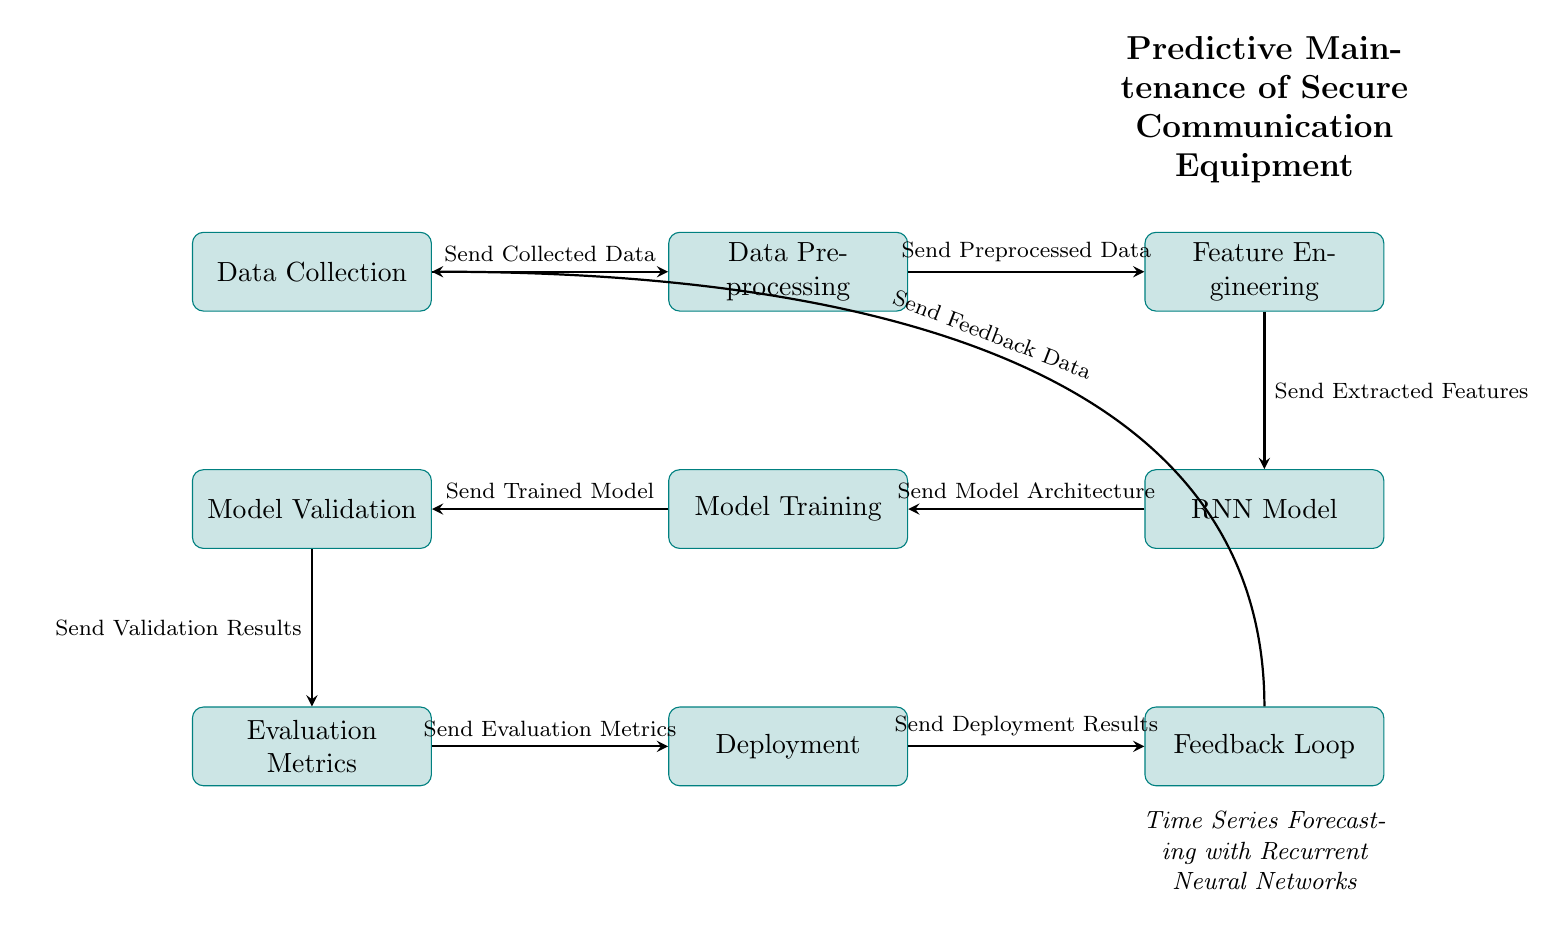What is the first step in the process? The first step in the process is represented by the node labeled "Data Collection," which is the starting point where relevant data is gathered before any further processing.
Answer: Data Collection How many main processes are there in the diagram? The diagram features eight main processes, which include Data Collection, Data Preprocessing, Feature Engineering, RNN Model, Model Training, Model Validation, Evaluation Metrics, Deployment, and Feedback Loop.
Answer: Eight What is the output from the "Feature Engineering" node? The output from the "Feature Engineering" node is labeled "Send Extracted Features," indicating the information sent to the next step in the workflow.
Answer: Send Extracted Features What follows "Model Training" in the workflow? Following "Model Training," the next step is "Model Validation," which evaluates the trained model to ensure its performance before it can be deployed.
Answer: Model Validation Which node is linked to "Data Collection" by a feedback loop? The node linked to "Data Collection" by the feedback loop is "Feedback Loop," indicating that the outcome from the deployment phase eventually circles back to improve or update the initial data collection process.
Answer: Feedback Loop How do the "Data Preprocessing" and "Feature Engineering" nodes relate to one another? "Data Preprocessing" sends preprocessed data to "Feature Engineering," establishing a sequential relationship where the output of the former is the input for the latter, ensuring that features extracted are based on cleaned data.
Answer: Send Preprocessed Data What is the purpose of the "Evaluation Metrics" node? The purpose of the "Evaluation Metrics" node is to assess the performance of the model after validation, providing necessary metrics that indicate how well the model is performing based on specific benchmarks.
Answer: Assessment of model performance What type of model is illustrated in the diagram? The diagram illustrates a Recurrent Neural Network (RNN) model, which is suitable for time series forecasting tasks due to its capacity to consider past information.
Answer: Recurrent Neural Network What is sent after receiving "Validation Results"? After receiving "Validation Results" from the "Model Validation" node, the next step is to send these results to the "Evaluation Metrics" node, which uses them to evaluate the model's effectiveness.
Answer: Send Validation Results 